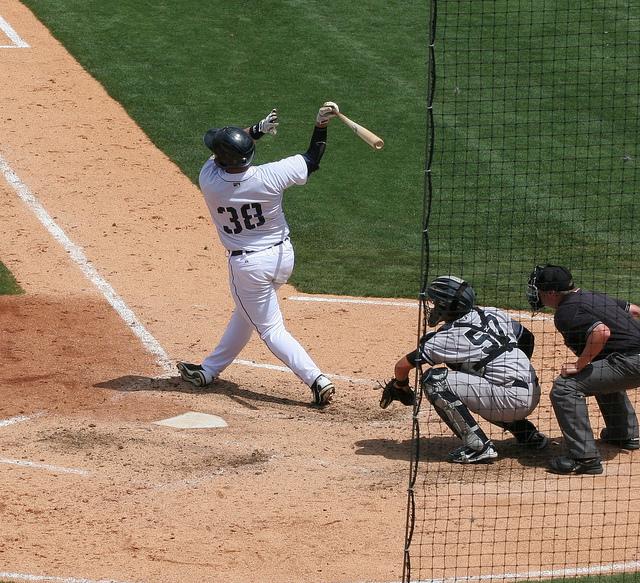What number is the batter?
Keep it brief. 38. What number is on the catcher's uniform?
Quick response, please. 57. What is the man about to throw?
Write a very short answer. Bat. Why is the batter's left leg bent?
Answer briefly. Swinging bat. How many people are standing up?
Concise answer only. 1. How many shoes are visible?
Answer briefly. 6. Is he a left handed hitter?
Be succinct. No. 